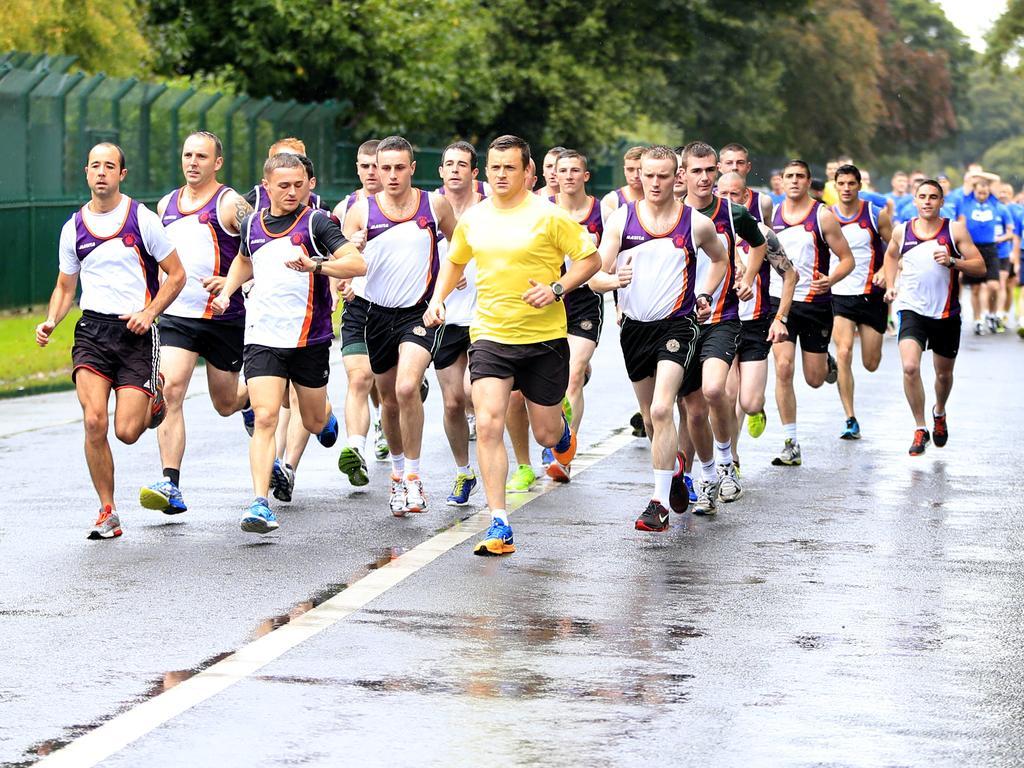Describe this image in one or two sentences. This picture is clicked outside. In the center we can see the group of persons wearing t-shirts and running on the road. In the background we can see the metal rods, green grass, mesh, trees and some other objects. 